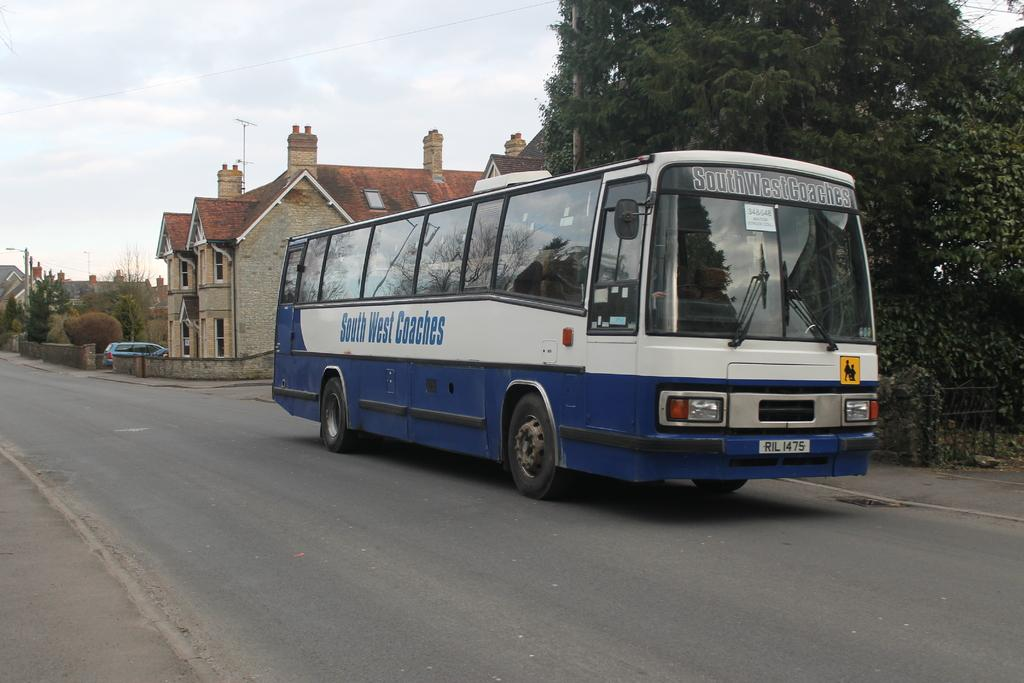What type of vehicle is on the road in the image? There is a bus on the road in the image. What feature of the bus is mentioned in the facts? The bus has wheels. How would you describe the sky in the image? The sky is cloudy in the image. What can be seen beside the bus? There are trees and houses with windows beside the bus. Can you describe any other vehicles in the image? There is a blue car far from the bus. What type of doctor is standing near the bus in the image? There is no doctor present in the image. What color bead can be seen hanging from the trees beside the bus? There are no beads visible in the image; only trees and houses are mentioned. 